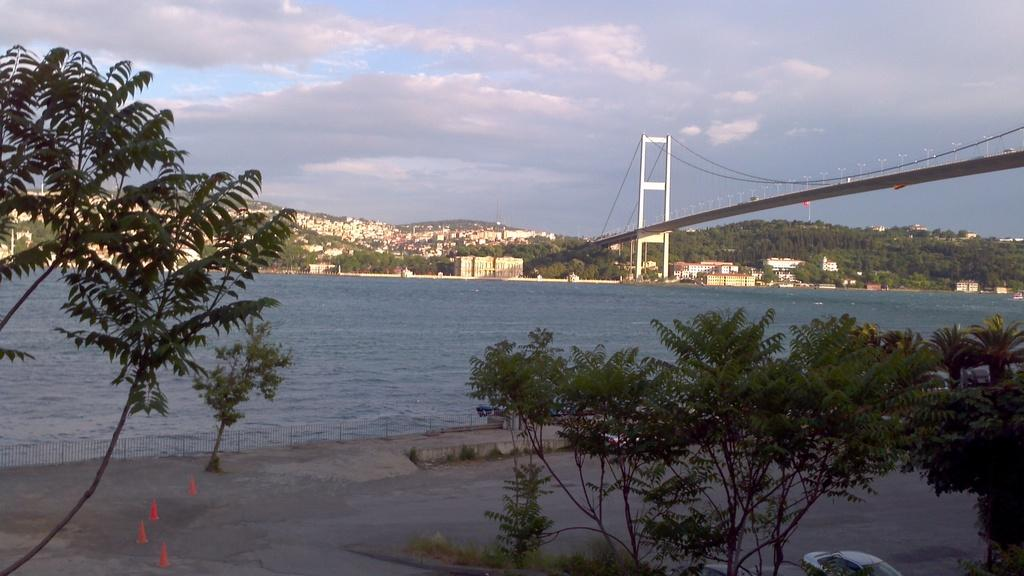Where is the image taken? The image is taken near a river. What can be seen crossing the river in the image? There is a bridge across the river in the image. What type of vegetation is present near the river? Trees are present on both sides of the river in the image. What type of mailbox can be seen near the river in the image? There is no mailbox present in the image. How does the ice form on the bridge in the image? There is no ice present in the image, and the bridge is not shown to be covered in ice. 